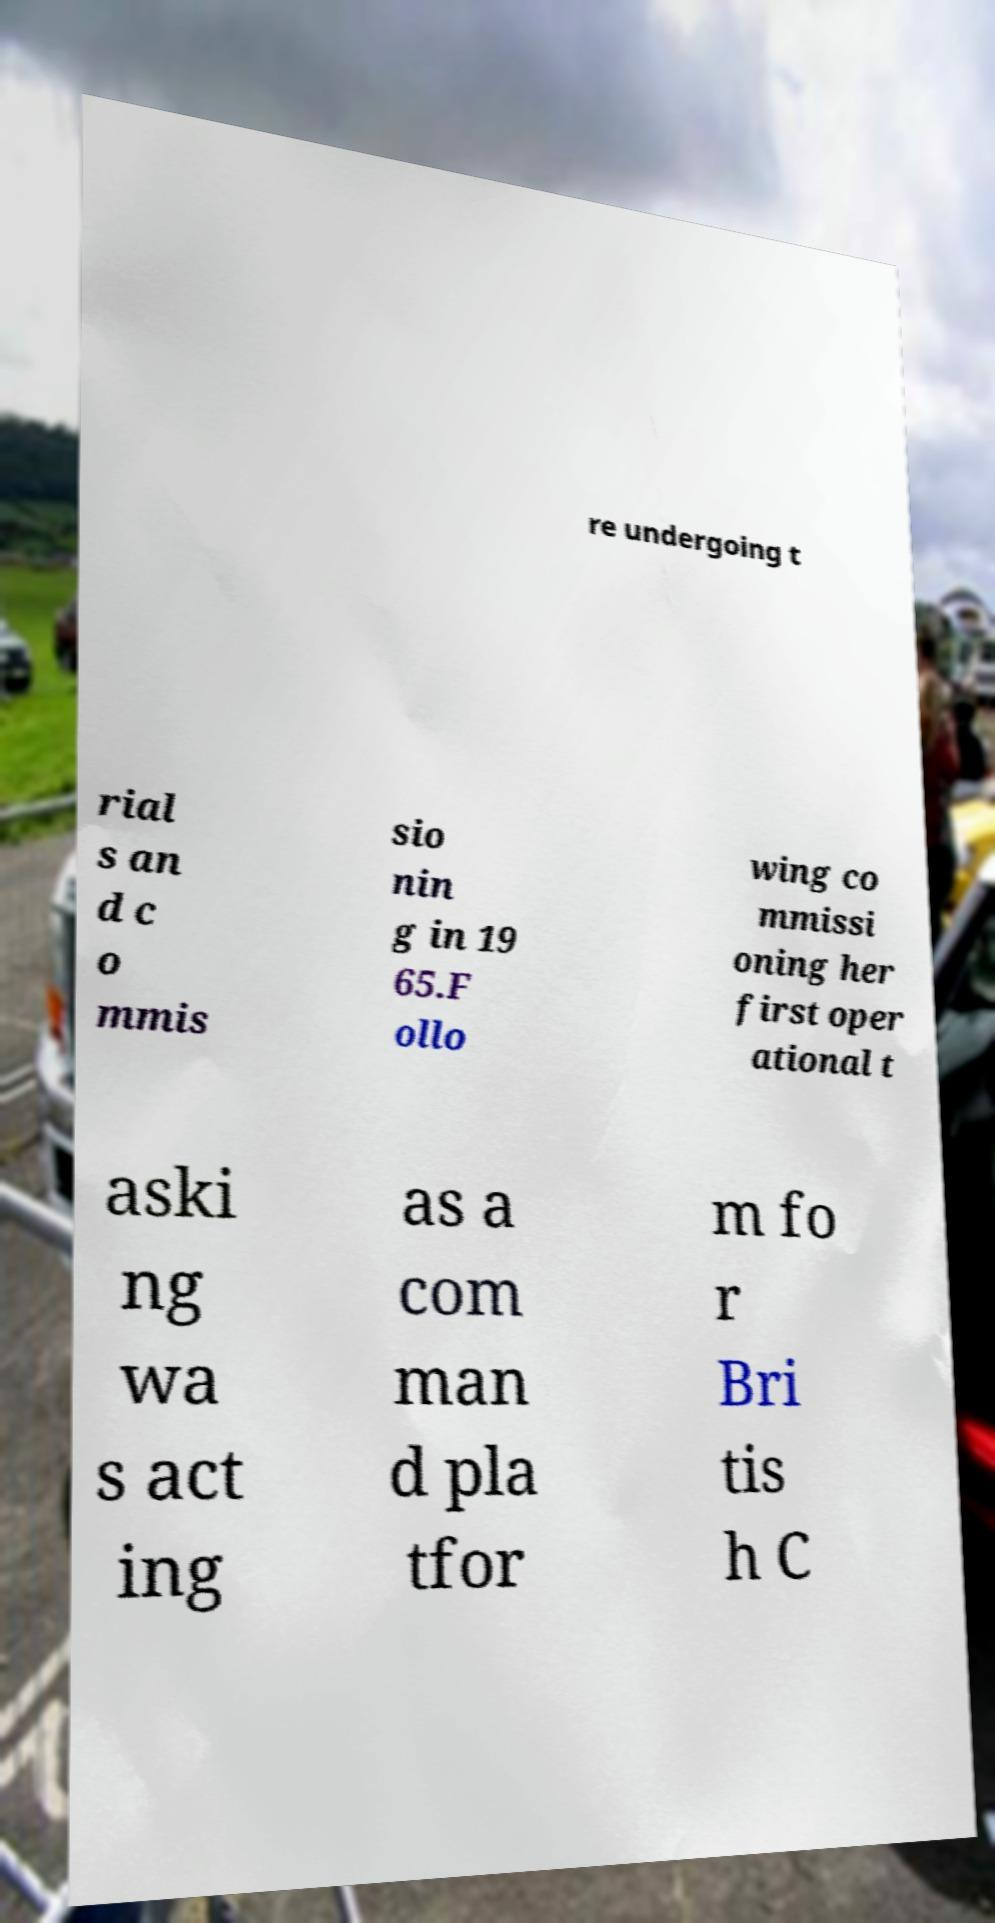There's text embedded in this image that I need extracted. Can you transcribe it verbatim? re undergoing t rial s an d c o mmis sio nin g in 19 65.F ollo wing co mmissi oning her first oper ational t aski ng wa s act ing as a com man d pla tfor m fo r Bri tis h C 